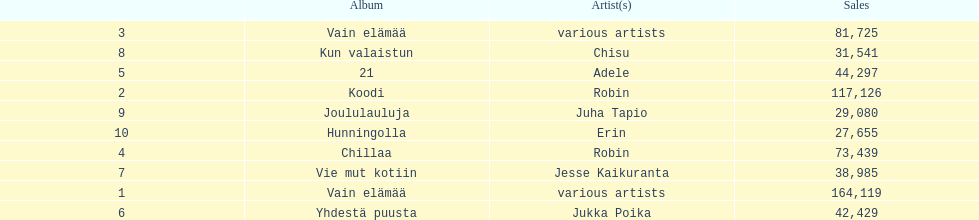Parse the full table. {'header': ['', 'Album', 'Artist(s)', 'Sales'], 'rows': [['3', 'Vain elämää', 'various artists', '81,725'], ['8', 'Kun valaistun', 'Chisu', '31,541'], ['5', '21', 'Adele', '44,297'], ['2', 'Koodi', 'Robin', '117,126'], ['9', 'Joululauluja', 'Juha Tapio', '29,080'], ['10', 'Hunningolla', 'Erin', '27,655'], ['4', 'Chillaa', 'Robin', '73,439'], ['7', 'Vie mut kotiin', 'Jesse Kaikuranta', '38,985'], ['1', 'Vain elämää', 'various artists', '164,119'], ['6', 'Yhdestä puusta', 'Jukka Poika', '42,429']]} Tell me what album had the most sold. Vain elämää. 